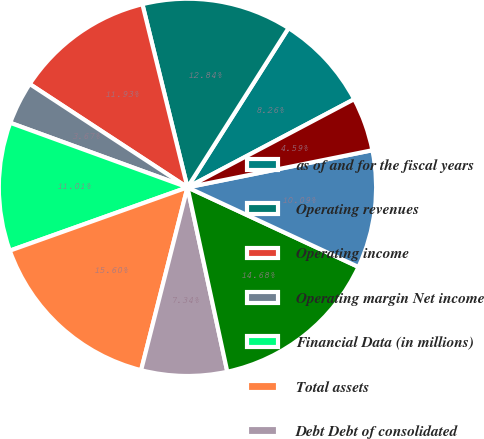<chart> <loc_0><loc_0><loc_500><loc_500><pie_chart><fcel>as of and for the fiscal years<fcel>Operating revenues<fcel>Operating income<fcel>Operating margin Net income<fcel>Financial Data (in millions)<fcel>Total assets<fcel>Debt Debt of consolidated<fcel>Franklin Resources Inc<fcel>Operating cash flows<fcel>Investing cash flows<nl><fcel>8.26%<fcel>12.84%<fcel>11.93%<fcel>3.67%<fcel>11.01%<fcel>15.6%<fcel>7.34%<fcel>14.68%<fcel>10.09%<fcel>4.59%<nl></chart> 